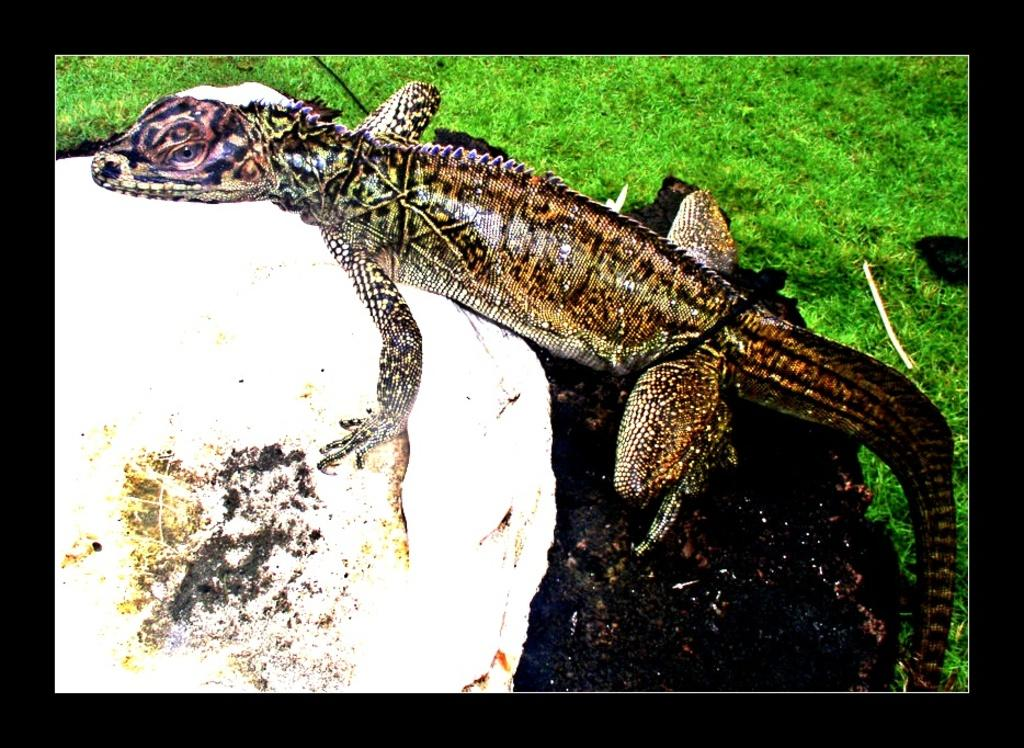What type of animal is in the image? There is a reptile in the image. What color is the reptile? The reptile is brown in color. What can be seen in the background of the image? There is grass in the background of the image. What color is the grass? The grass is green in color. How does the reptile expand its territory in the image? The image does not show the reptile expanding its territory; it only depicts the reptile's appearance and the background setting. 